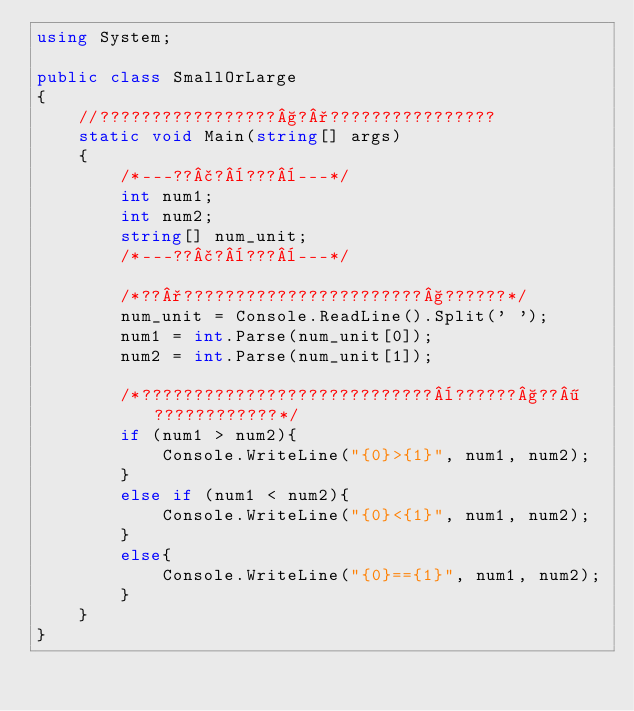<code> <loc_0><loc_0><loc_500><loc_500><_C#_>using System;

public class SmallOrLarge
{
    //?????????????????§?°????????????????
    static void Main(string[] args)
    {
        /*---??£?¨???¨---*/
        int num1;
        int num2;
        string[] num_unit;
        /*---??£?¨???¨---*/

        /*??°???????????????????????§??????*/
        num_unit = Console.ReadLine().Split(' ');
        num1 = int.Parse(num_unit[0]);
        num2 = int.Parse(num_unit[1]);

        /*????????????????????????????¨??????§??¶????????????*/
        if (num1 > num2){
            Console.WriteLine("{0}>{1}", num1, num2);
        }
        else if (num1 < num2){
            Console.WriteLine("{0}<{1}", num1, num2);
        }
        else{
            Console.WriteLine("{0}=={1}", num1, num2);
        }
    }
}</code> 